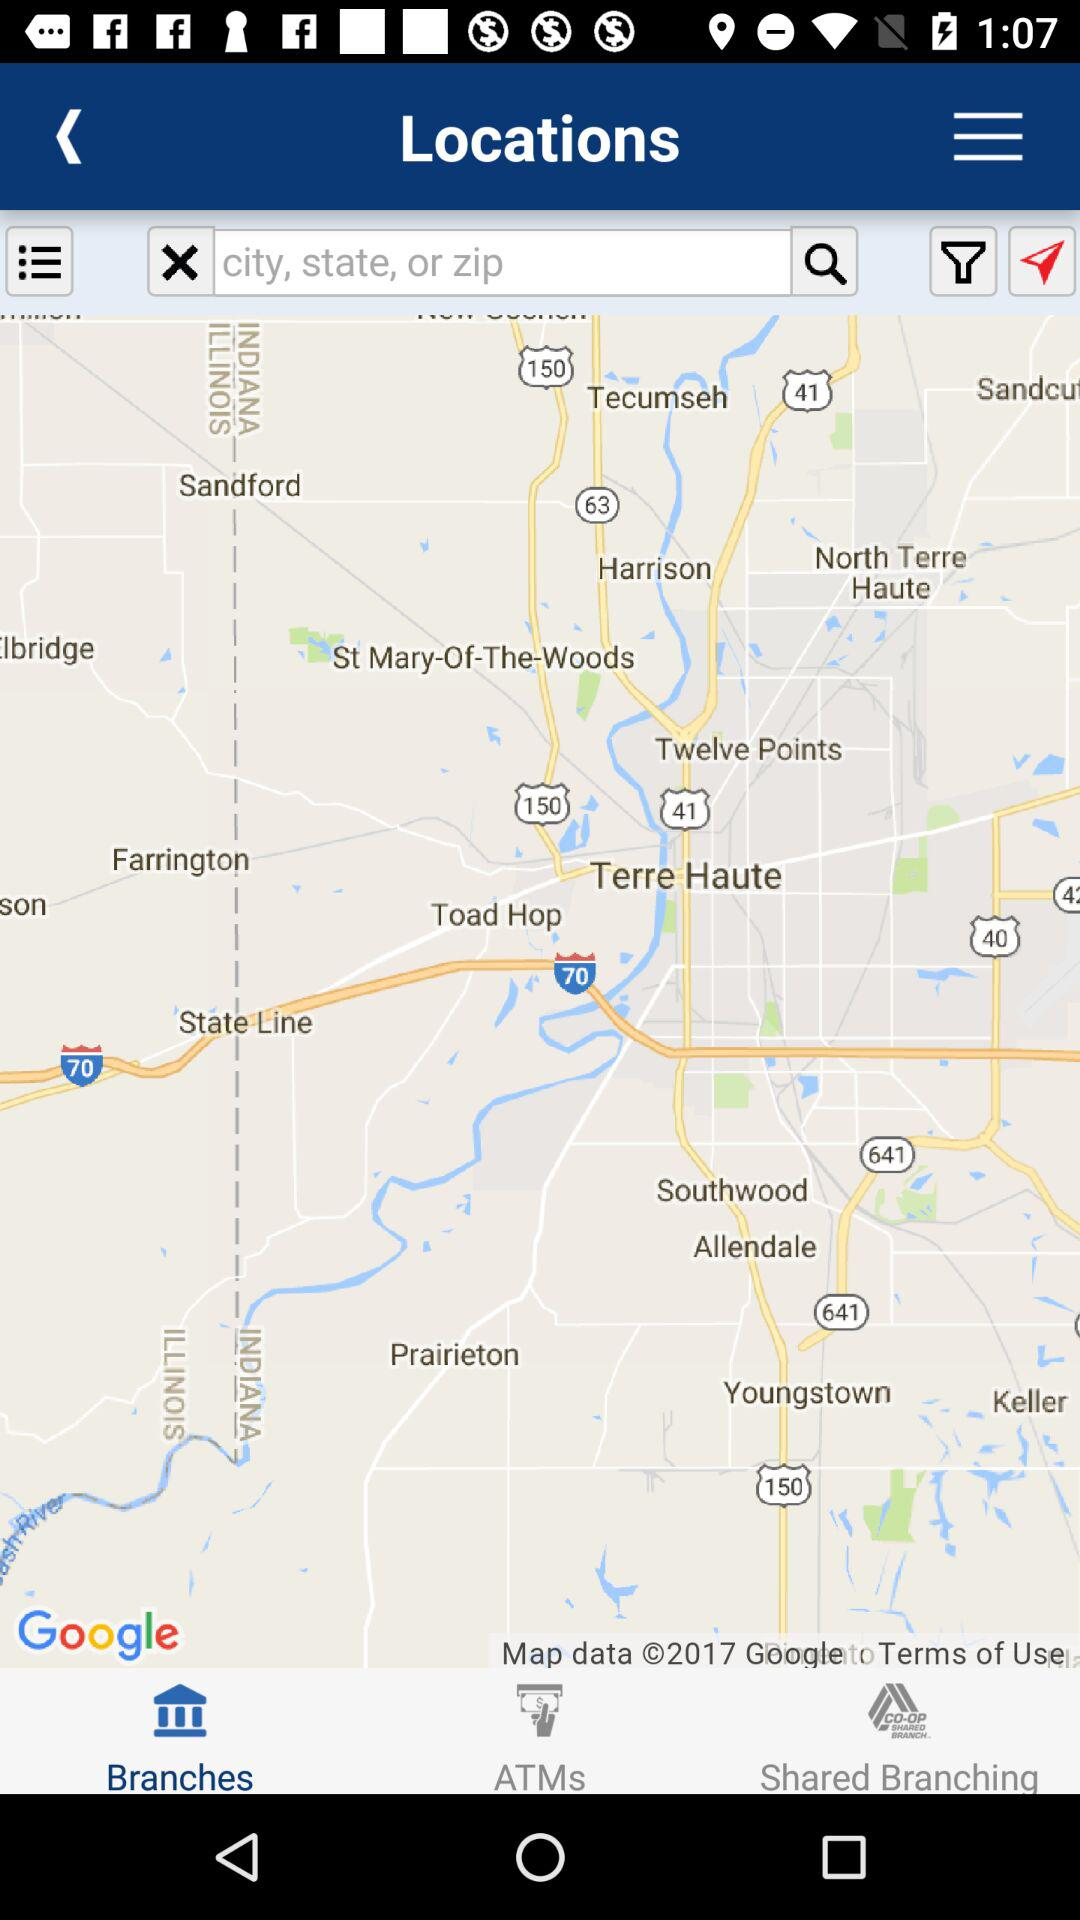Which tab is selected? The selected tab is "Branches". 